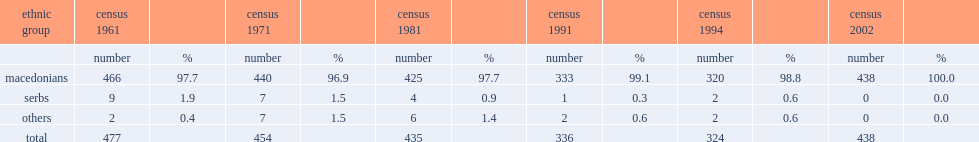How many inhabitants did stenje have totally? 438.0. 